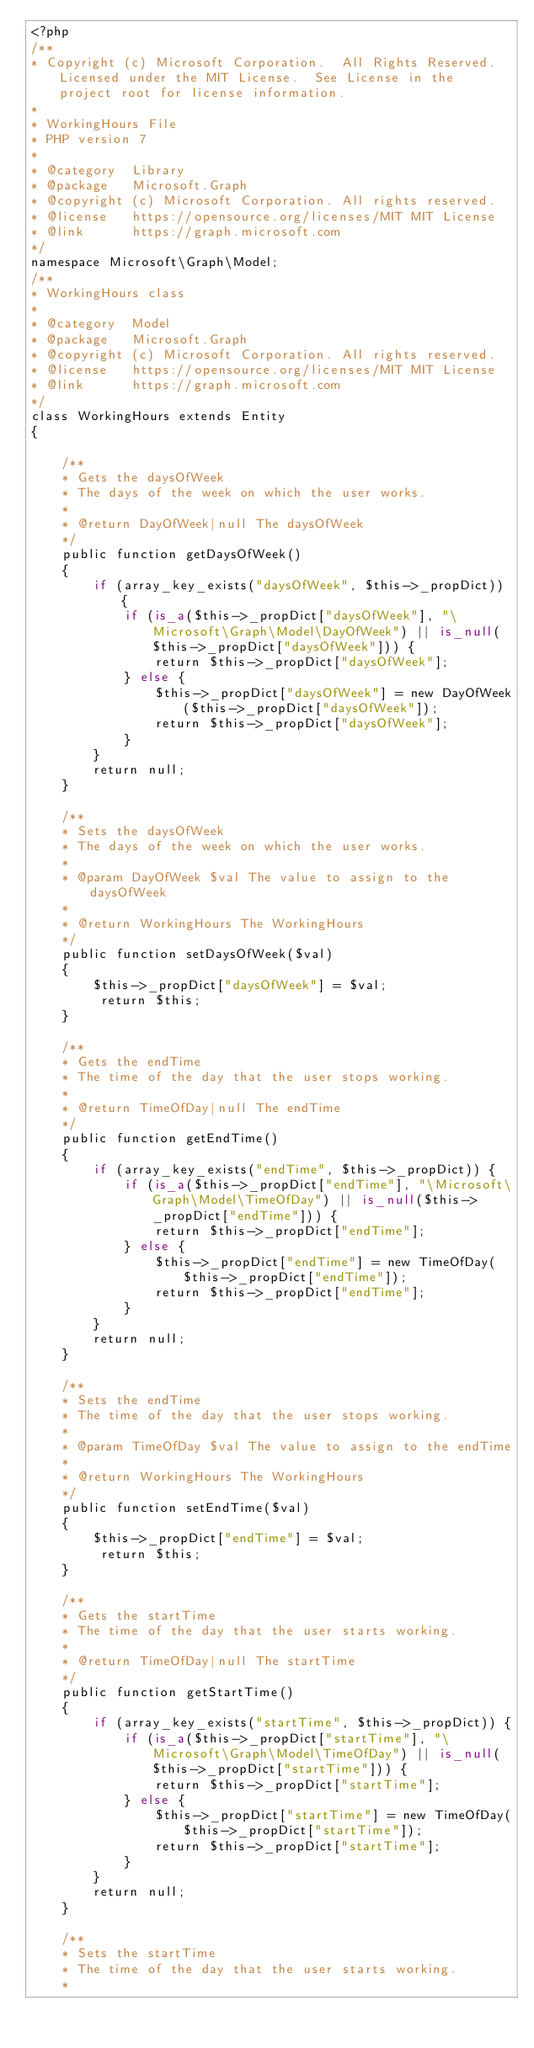<code> <loc_0><loc_0><loc_500><loc_500><_PHP_><?php
/**
* Copyright (c) Microsoft Corporation.  All Rights Reserved.  Licensed under the MIT License.  See License in the project root for license information.
* 
* WorkingHours File
* PHP version 7
*
* @category  Library
* @package   Microsoft.Graph
* @copyright (c) Microsoft Corporation. All rights reserved.
* @license   https://opensource.org/licenses/MIT MIT License
* @link      https://graph.microsoft.com
*/
namespace Microsoft\Graph\Model;
/**
* WorkingHours class
*
* @category  Model
* @package   Microsoft.Graph
* @copyright (c) Microsoft Corporation. All rights reserved.
* @license   https://opensource.org/licenses/MIT MIT License
* @link      https://graph.microsoft.com
*/
class WorkingHours extends Entity
{

    /**
    * Gets the daysOfWeek
    * The days of the week on which the user works.
    *
    * @return DayOfWeek|null The daysOfWeek
    */
    public function getDaysOfWeek()
    {
        if (array_key_exists("daysOfWeek", $this->_propDict)) {
            if (is_a($this->_propDict["daysOfWeek"], "\Microsoft\Graph\Model\DayOfWeek") || is_null($this->_propDict["daysOfWeek"])) {
                return $this->_propDict["daysOfWeek"];
            } else {
                $this->_propDict["daysOfWeek"] = new DayOfWeek($this->_propDict["daysOfWeek"]);
                return $this->_propDict["daysOfWeek"];
            }
        }
        return null;
    }

    /**
    * Sets the daysOfWeek
    * The days of the week on which the user works.
    *
    * @param DayOfWeek $val The value to assign to the daysOfWeek
    *
    * @return WorkingHours The WorkingHours
    */
    public function setDaysOfWeek($val)
    {
        $this->_propDict["daysOfWeek"] = $val;
         return $this;
    }

    /**
    * Gets the endTime
    * The time of the day that the user stops working.
    *
    * @return TimeOfDay|null The endTime
    */
    public function getEndTime()
    {
        if (array_key_exists("endTime", $this->_propDict)) {
            if (is_a($this->_propDict["endTime"], "\Microsoft\Graph\Model\TimeOfDay") || is_null($this->_propDict["endTime"])) {
                return $this->_propDict["endTime"];
            } else {
                $this->_propDict["endTime"] = new TimeOfDay($this->_propDict["endTime"]);
                return $this->_propDict["endTime"];
            }
        }
        return null;
    }

    /**
    * Sets the endTime
    * The time of the day that the user stops working.
    *
    * @param TimeOfDay $val The value to assign to the endTime
    *
    * @return WorkingHours The WorkingHours
    */
    public function setEndTime($val)
    {
        $this->_propDict["endTime"] = $val;
         return $this;
    }

    /**
    * Gets the startTime
    * The time of the day that the user starts working.
    *
    * @return TimeOfDay|null The startTime
    */
    public function getStartTime()
    {
        if (array_key_exists("startTime", $this->_propDict)) {
            if (is_a($this->_propDict["startTime"], "\Microsoft\Graph\Model\TimeOfDay") || is_null($this->_propDict["startTime"])) {
                return $this->_propDict["startTime"];
            } else {
                $this->_propDict["startTime"] = new TimeOfDay($this->_propDict["startTime"]);
                return $this->_propDict["startTime"];
            }
        }
        return null;
    }

    /**
    * Sets the startTime
    * The time of the day that the user starts working.
    *</code> 